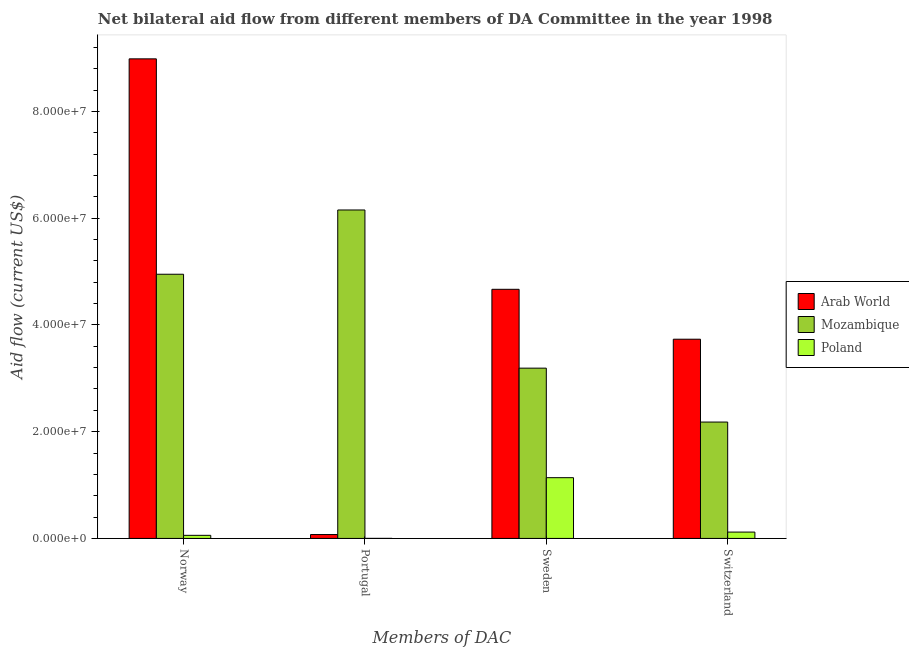How many groups of bars are there?
Give a very brief answer. 4. Are the number of bars per tick equal to the number of legend labels?
Keep it short and to the point. Yes. Are the number of bars on each tick of the X-axis equal?
Make the answer very short. Yes. How many bars are there on the 2nd tick from the left?
Keep it short and to the point. 3. What is the label of the 3rd group of bars from the left?
Ensure brevity in your answer.  Sweden. What is the amount of aid given by portugal in Mozambique?
Ensure brevity in your answer.  6.15e+07. Across all countries, what is the maximum amount of aid given by norway?
Ensure brevity in your answer.  8.98e+07. Across all countries, what is the minimum amount of aid given by portugal?
Keep it short and to the point. 10000. In which country was the amount of aid given by sweden maximum?
Offer a terse response. Arab World. In which country was the amount of aid given by sweden minimum?
Make the answer very short. Poland. What is the total amount of aid given by switzerland in the graph?
Make the answer very short. 6.03e+07. What is the difference between the amount of aid given by switzerland in Arab World and that in Mozambique?
Ensure brevity in your answer.  1.55e+07. What is the difference between the amount of aid given by portugal in Poland and the amount of aid given by switzerland in Arab World?
Keep it short and to the point. -3.73e+07. What is the average amount of aid given by sweden per country?
Give a very brief answer. 3.00e+07. What is the difference between the amount of aid given by sweden and amount of aid given by switzerland in Poland?
Offer a very short reply. 1.02e+07. In how many countries, is the amount of aid given by norway greater than 68000000 US$?
Your answer should be compact. 1. What is the ratio of the amount of aid given by sweden in Mozambique to that in Poland?
Your answer should be compact. 2.8. What is the difference between the highest and the second highest amount of aid given by portugal?
Your answer should be very brief. 6.08e+07. What is the difference between the highest and the lowest amount of aid given by norway?
Ensure brevity in your answer.  8.93e+07. In how many countries, is the amount of aid given by norway greater than the average amount of aid given by norway taken over all countries?
Ensure brevity in your answer.  2. Is the sum of the amount of aid given by norway in Poland and Mozambique greater than the maximum amount of aid given by sweden across all countries?
Your response must be concise. Yes. What does the 2nd bar from the left in Sweden represents?
Provide a succinct answer. Mozambique. What does the 1st bar from the right in Switzerland represents?
Offer a very short reply. Poland. Are all the bars in the graph horizontal?
Make the answer very short. No. How many legend labels are there?
Your response must be concise. 3. What is the title of the graph?
Provide a succinct answer. Net bilateral aid flow from different members of DA Committee in the year 1998. Does "Haiti" appear as one of the legend labels in the graph?
Your response must be concise. No. What is the label or title of the X-axis?
Provide a succinct answer. Members of DAC. What is the label or title of the Y-axis?
Your answer should be compact. Aid flow (current US$). What is the Aid flow (current US$) in Arab World in Norway?
Offer a very short reply. 8.98e+07. What is the Aid flow (current US$) in Mozambique in Norway?
Your answer should be very brief. 4.95e+07. What is the Aid flow (current US$) in Poland in Norway?
Ensure brevity in your answer.  5.80e+05. What is the Aid flow (current US$) of Arab World in Portugal?
Offer a terse response. 7.30e+05. What is the Aid flow (current US$) of Mozambique in Portugal?
Offer a terse response. 6.15e+07. What is the Aid flow (current US$) of Poland in Portugal?
Make the answer very short. 10000. What is the Aid flow (current US$) of Arab World in Sweden?
Give a very brief answer. 4.67e+07. What is the Aid flow (current US$) in Mozambique in Sweden?
Provide a short and direct response. 3.19e+07. What is the Aid flow (current US$) in Poland in Sweden?
Offer a very short reply. 1.14e+07. What is the Aid flow (current US$) of Arab World in Switzerland?
Make the answer very short. 3.73e+07. What is the Aid flow (current US$) in Mozambique in Switzerland?
Your answer should be very brief. 2.18e+07. What is the Aid flow (current US$) in Poland in Switzerland?
Provide a succinct answer. 1.19e+06. Across all Members of DAC, what is the maximum Aid flow (current US$) of Arab World?
Provide a short and direct response. 8.98e+07. Across all Members of DAC, what is the maximum Aid flow (current US$) in Mozambique?
Offer a very short reply. 6.15e+07. Across all Members of DAC, what is the maximum Aid flow (current US$) of Poland?
Offer a terse response. 1.14e+07. Across all Members of DAC, what is the minimum Aid flow (current US$) in Arab World?
Give a very brief answer. 7.30e+05. Across all Members of DAC, what is the minimum Aid flow (current US$) of Mozambique?
Offer a terse response. 2.18e+07. What is the total Aid flow (current US$) of Arab World in the graph?
Provide a succinct answer. 1.75e+08. What is the total Aid flow (current US$) in Mozambique in the graph?
Offer a terse response. 1.65e+08. What is the total Aid flow (current US$) in Poland in the graph?
Your answer should be very brief. 1.32e+07. What is the difference between the Aid flow (current US$) in Arab World in Norway and that in Portugal?
Make the answer very short. 8.91e+07. What is the difference between the Aid flow (current US$) of Mozambique in Norway and that in Portugal?
Offer a terse response. -1.20e+07. What is the difference between the Aid flow (current US$) of Poland in Norway and that in Portugal?
Keep it short and to the point. 5.70e+05. What is the difference between the Aid flow (current US$) of Arab World in Norway and that in Sweden?
Offer a very short reply. 4.32e+07. What is the difference between the Aid flow (current US$) in Mozambique in Norway and that in Sweden?
Offer a very short reply. 1.76e+07. What is the difference between the Aid flow (current US$) in Poland in Norway and that in Sweden?
Your response must be concise. -1.08e+07. What is the difference between the Aid flow (current US$) of Arab World in Norway and that in Switzerland?
Your answer should be very brief. 5.25e+07. What is the difference between the Aid flow (current US$) of Mozambique in Norway and that in Switzerland?
Provide a short and direct response. 2.77e+07. What is the difference between the Aid flow (current US$) in Poland in Norway and that in Switzerland?
Provide a succinct answer. -6.10e+05. What is the difference between the Aid flow (current US$) of Arab World in Portugal and that in Sweden?
Your answer should be very brief. -4.59e+07. What is the difference between the Aid flow (current US$) of Mozambique in Portugal and that in Sweden?
Offer a terse response. 2.96e+07. What is the difference between the Aid flow (current US$) in Poland in Portugal and that in Sweden?
Your answer should be compact. -1.14e+07. What is the difference between the Aid flow (current US$) in Arab World in Portugal and that in Switzerland?
Your answer should be compact. -3.66e+07. What is the difference between the Aid flow (current US$) in Mozambique in Portugal and that in Switzerland?
Make the answer very short. 3.97e+07. What is the difference between the Aid flow (current US$) in Poland in Portugal and that in Switzerland?
Offer a terse response. -1.18e+06. What is the difference between the Aid flow (current US$) in Arab World in Sweden and that in Switzerland?
Keep it short and to the point. 9.35e+06. What is the difference between the Aid flow (current US$) of Mozambique in Sweden and that in Switzerland?
Provide a short and direct response. 1.01e+07. What is the difference between the Aid flow (current US$) in Poland in Sweden and that in Switzerland?
Ensure brevity in your answer.  1.02e+07. What is the difference between the Aid flow (current US$) of Arab World in Norway and the Aid flow (current US$) of Mozambique in Portugal?
Keep it short and to the point. 2.83e+07. What is the difference between the Aid flow (current US$) of Arab World in Norway and the Aid flow (current US$) of Poland in Portugal?
Your response must be concise. 8.98e+07. What is the difference between the Aid flow (current US$) of Mozambique in Norway and the Aid flow (current US$) of Poland in Portugal?
Ensure brevity in your answer.  4.95e+07. What is the difference between the Aid flow (current US$) in Arab World in Norway and the Aid flow (current US$) in Mozambique in Sweden?
Provide a short and direct response. 5.79e+07. What is the difference between the Aid flow (current US$) in Arab World in Norway and the Aid flow (current US$) in Poland in Sweden?
Your answer should be compact. 7.85e+07. What is the difference between the Aid flow (current US$) of Mozambique in Norway and the Aid flow (current US$) of Poland in Sweden?
Ensure brevity in your answer.  3.81e+07. What is the difference between the Aid flow (current US$) of Arab World in Norway and the Aid flow (current US$) of Mozambique in Switzerland?
Your response must be concise. 6.80e+07. What is the difference between the Aid flow (current US$) in Arab World in Norway and the Aid flow (current US$) in Poland in Switzerland?
Your response must be concise. 8.86e+07. What is the difference between the Aid flow (current US$) in Mozambique in Norway and the Aid flow (current US$) in Poland in Switzerland?
Provide a short and direct response. 4.83e+07. What is the difference between the Aid flow (current US$) in Arab World in Portugal and the Aid flow (current US$) in Mozambique in Sweden?
Make the answer very short. -3.12e+07. What is the difference between the Aid flow (current US$) of Arab World in Portugal and the Aid flow (current US$) of Poland in Sweden?
Your answer should be very brief. -1.06e+07. What is the difference between the Aid flow (current US$) of Mozambique in Portugal and the Aid flow (current US$) of Poland in Sweden?
Ensure brevity in your answer.  5.02e+07. What is the difference between the Aid flow (current US$) of Arab World in Portugal and the Aid flow (current US$) of Mozambique in Switzerland?
Provide a short and direct response. -2.11e+07. What is the difference between the Aid flow (current US$) in Arab World in Portugal and the Aid flow (current US$) in Poland in Switzerland?
Your answer should be compact. -4.60e+05. What is the difference between the Aid flow (current US$) of Mozambique in Portugal and the Aid flow (current US$) of Poland in Switzerland?
Offer a terse response. 6.03e+07. What is the difference between the Aid flow (current US$) in Arab World in Sweden and the Aid flow (current US$) in Mozambique in Switzerland?
Provide a succinct answer. 2.49e+07. What is the difference between the Aid flow (current US$) of Arab World in Sweden and the Aid flow (current US$) of Poland in Switzerland?
Give a very brief answer. 4.55e+07. What is the difference between the Aid flow (current US$) in Mozambique in Sweden and the Aid flow (current US$) in Poland in Switzerland?
Your answer should be compact. 3.07e+07. What is the average Aid flow (current US$) of Arab World per Members of DAC?
Offer a terse response. 4.36e+07. What is the average Aid flow (current US$) of Mozambique per Members of DAC?
Ensure brevity in your answer.  4.12e+07. What is the average Aid flow (current US$) in Poland per Members of DAC?
Give a very brief answer. 3.29e+06. What is the difference between the Aid flow (current US$) in Arab World and Aid flow (current US$) in Mozambique in Norway?
Your answer should be very brief. 4.04e+07. What is the difference between the Aid flow (current US$) of Arab World and Aid flow (current US$) of Poland in Norway?
Your response must be concise. 8.93e+07. What is the difference between the Aid flow (current US$) in Mozambique and Aid flow (current US$) in Poland in Norway?
Your answer should be compact. 4.89e+07. What is the difference between the Aid flow (current US$) of Arab World and Aid flow (current US$) of Mozambique in Portugal?
Ensure brevity in your answer.  -6.08e+07. What is the difference between the Aid flow (current US$) in Arab World and Aid flow (current US$) in Poland in Portugal?
Make the answer very short. 7.20e+05. What is the difference between the Aid flow (current US$) of Mozambique and Aid flow (current US$) of Poland in Portugal?
Make the answer very short. 6.15e+07. What is the difference between the Aid flow (current US$) of Arab World and Aid flow (current US$) of Mozambique in Sweden?
Make the answer very short. 1.48e+07. What is the difference between the Aid flow (current US$) in Arab World and Aid flow (current US$) in Poland in Sweden?
Your answer should be very brief. 3.53e+07. What is the difference between the Aid flow (current US$) in Mozambique and Aid flow (current US$) in Poland in Sweden?
Provide a succinct answer. 2.05e+07. What is the difference between the Aid flow (current US$) of Arab World and Aid flow (current US$) of Mozambique in Switzerland?
Your response must be concise. 1.55e+07. What is the difference between the Aid flow (current US$) in Arab World and Aid flow (current US$) in Poland in Switzerland?
Your response must be concise. 3.61e+07. What is the difference between the Aid flow (current US$) of Mozambique and Aid flow (current US$) of Poland in Switzerland?
Offer a very short reply. 2.06e+07. What is the ratio of the Aid flow (current US$) in Arab World in Norway to that in Portugal?
Your answer should be very brief. 123.07. What is the ratio of the Aid flow (current US$) in Mozambique in Norway to that in Portugal?
Offer a terse response. 0.8. What is the ratio of the Aid flow (current US$) of Poland in Norway to that in Portugal?
Your response must be concise. 58. What is the ratio of the Aid flow (current US$) in Arab World in Norway to that in Sweden?
Your answer should be very brief. 1.93. What is the ratio of the Aid flow (current US$) of Mozambique in Norway to that in Sweden?
Provide a short and direct response. 1.55. What is the ratio of the Aid flow (current US$) in Poland in Norway to that in Sweden?
Provide a short and direct response. 0.05. What is the ratio of the Aid flow (current US$) in Arab World in Norway to that in Switzerland?
Offer a terse response. 2.41. What is the ratio of the Aid flow (current US$) in Mozambique in Norway to that in Switzerland?
Make the answer very short. 2.27. What is the ratio of the Aid flow (current US$) of Poland in Norway to that in Switzerland?
Offer a terse response. 0.49. What is the ratio of the Aid flow (current US$) of Arab World in Portugal to that in Sweden?
Provide a succinct answer. 0.02. What is the ratio of the Aid flow (current US$) in Mozambique in Portugal to that in Sweden?
Keep it short and to the point. 1.93. What is the ratio of the Aid flow (current US$) of Poland in Portugal to that in Sweden?
Provide a succinct answer. 0. What is the ratio of the Aid flow (current US$) of Arab World in Portugal to that in Switzerland?
Your response must be concise. 0.02. What is the ratio of the Aid flow (current US$) of Mozambique in Portugal to that in Switzerland?
Your answer should be compact. 2.82. What is the ratio of the Aid flow (current US$) in Poland in Portugal to that in Switzerland?
Provide a succinct answer. 0.01. What is the ratio of the Aid flow (current US$) in Arab World in Sweden to that in Switzerland?
Offer a very short reply. 1.25. What is the ratio of the Aid flow (current US$) in Mozambique in Sweden to that in Switzerland?
Provide a short and direct response. 1.46. What is the ratio of the Aid flow (current US$) in Poland in Sweden to that in Switzerland?
Provide a short and direct response. 9.56. What is the difference between the highest and the second highest Aid flow (current US$) in Arab World?
Provide a short and direct response. 4.32e+07. What is the difference between the highest and the second highest Aid flow (current US$) of Mozambique?
Your answer should be very brief. 1.20e+07. What is the difference between the highest and the second highest Aid flow (current US$) of Poland?
Your answer should be compact. 1.02e+07. What is the difference between the highest and the lowest Aid flow (current US$) in Arab World?
Your answer should be very brief. 8.91e+07. What is the difference between the highest and the lowest Aid flow (current US$) of Mozambique?
Ensure brevity in your answer.  3.97e+07. What is the difference between the highest and the lowest Aid flow (current US$) in Poland?
Make the answer very short. 1.14e+07. 